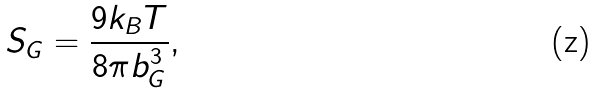<formula> <loc_0><loc_0><loc_500><loc_500>S _ { G } = \frac { 9 k _ { B } T } { 8 \pi b _ { G } ^ { 3 } } ,</formula> 